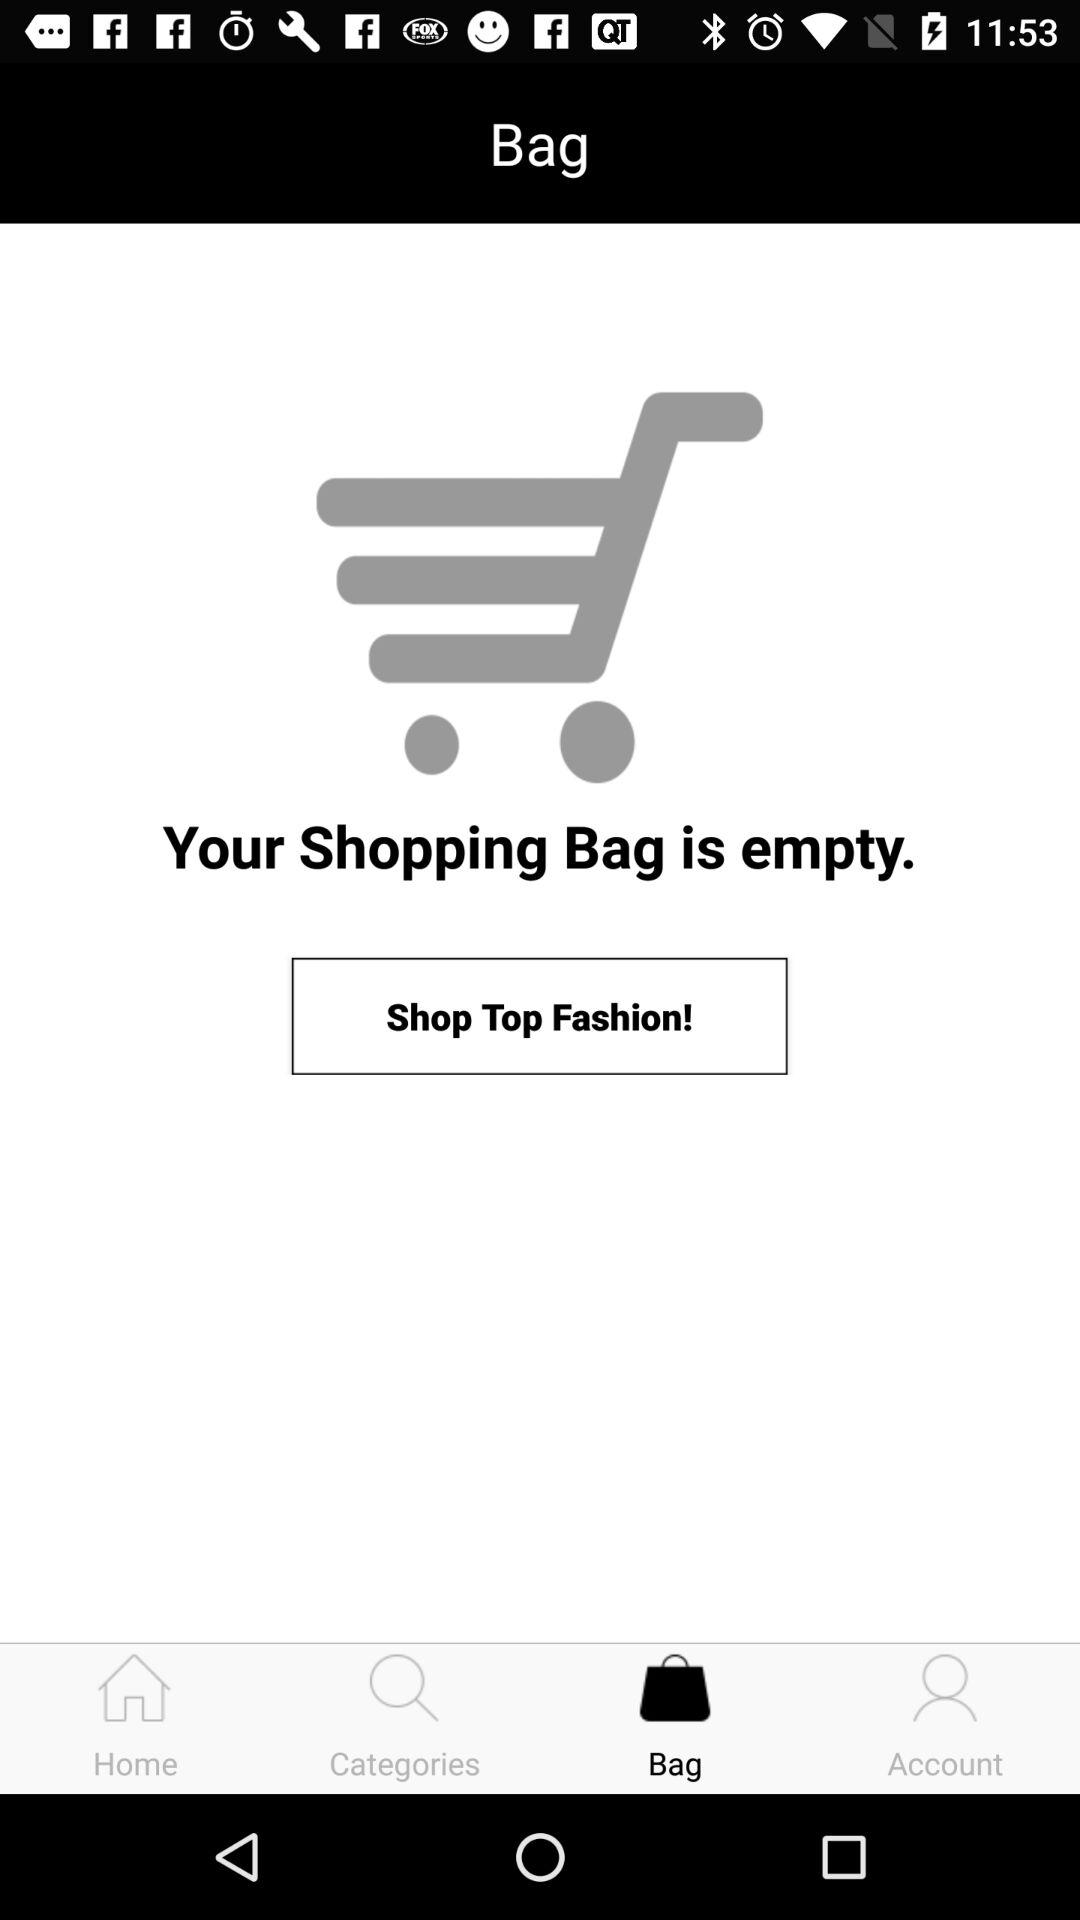How many items are in the shopping cart?
Answer the question using a single word or phrase. 0 